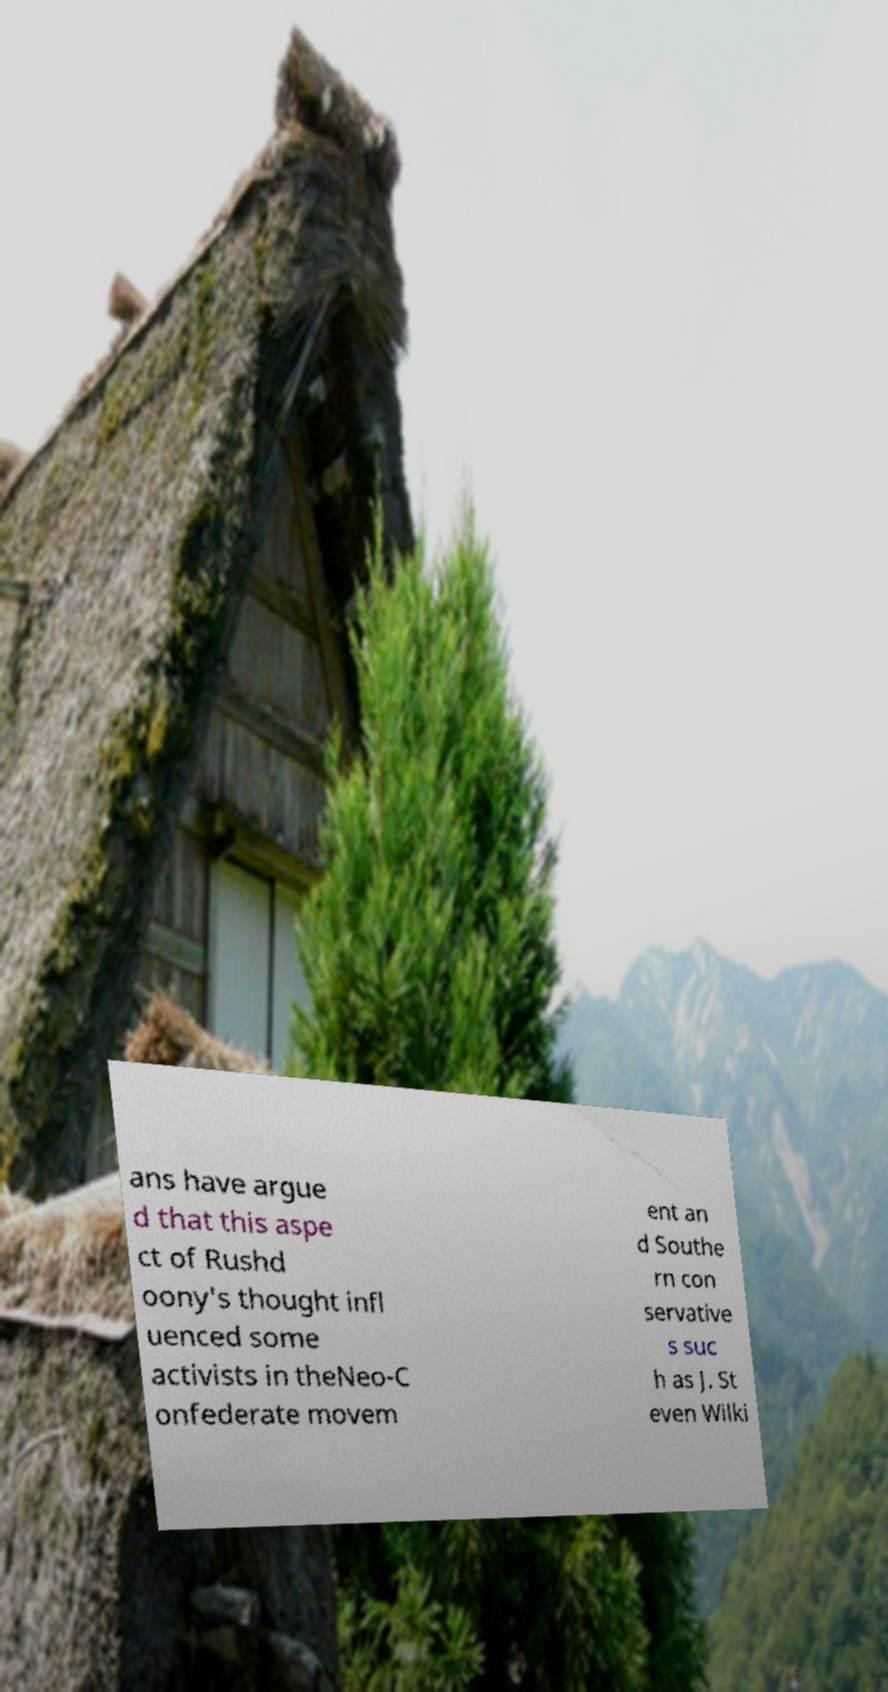Can you accurately transcribe the text from the provided image for me? ans have argue d that this aspe ct of Rushd oony's thought infl uenced some activists in theNeo-C onfederate movem ent an d Southe rn con servative s suc h as J. St even Wilki 